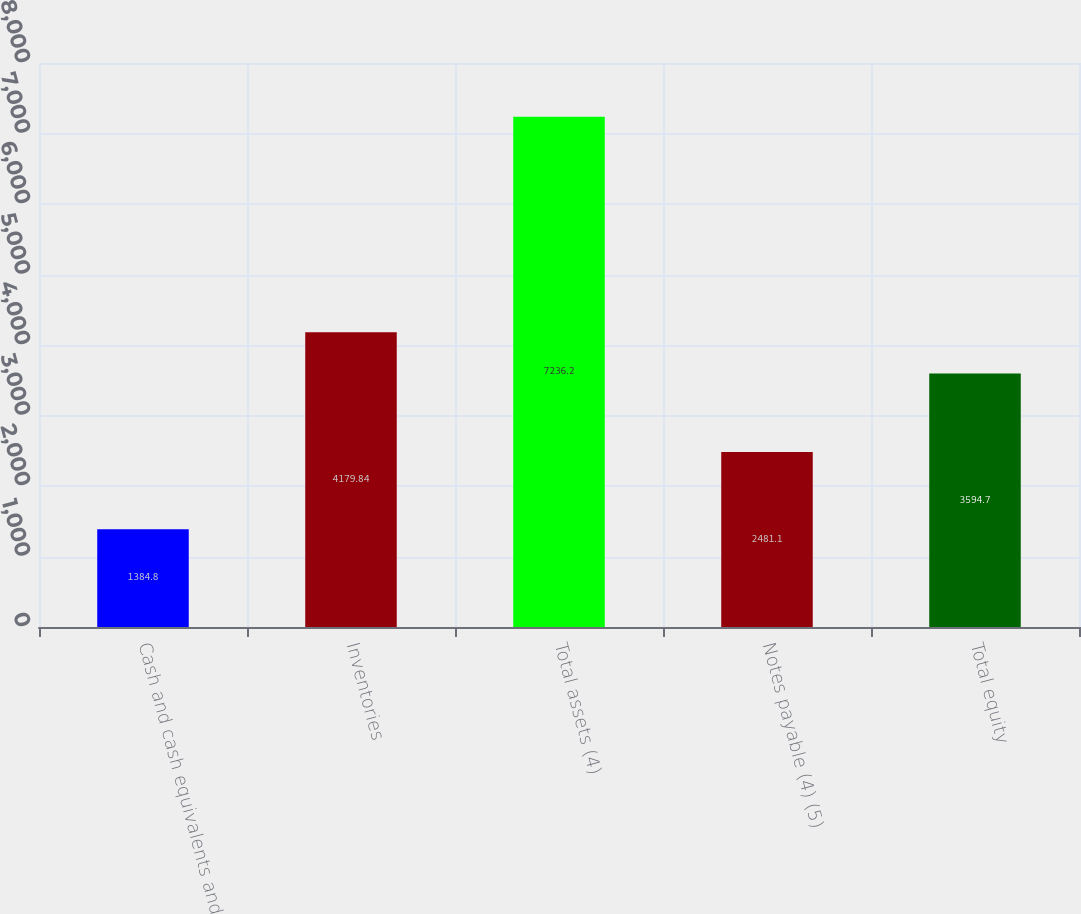<chart> <loc_0><loc_0><loc_500><loc_500><bar_chart><fcel>Cash and cash equivalents and<fcel>Inventories<fcel>Total assets (4)<fcel>Notes payable (4) (5)<fcel>Total equity<nl><fcel>1384.8<fcel>4179.84<fcel>7236.2<fcel>2481.1<fcel>3594.7<nl></chart> 